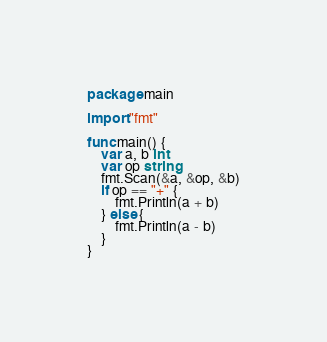Convert code to text. <code><loc_0><loc_0><loc_500><loc_500><_Go_>package main

import "fmt"

func main() {
	var a, b int
	var op string
	fmt.Scan(&a, &op, &b)
	if op == "+" {
		fmt.Println(a + b)
	} else {
		fmt.Println(a - b)
	}
}
</code> 